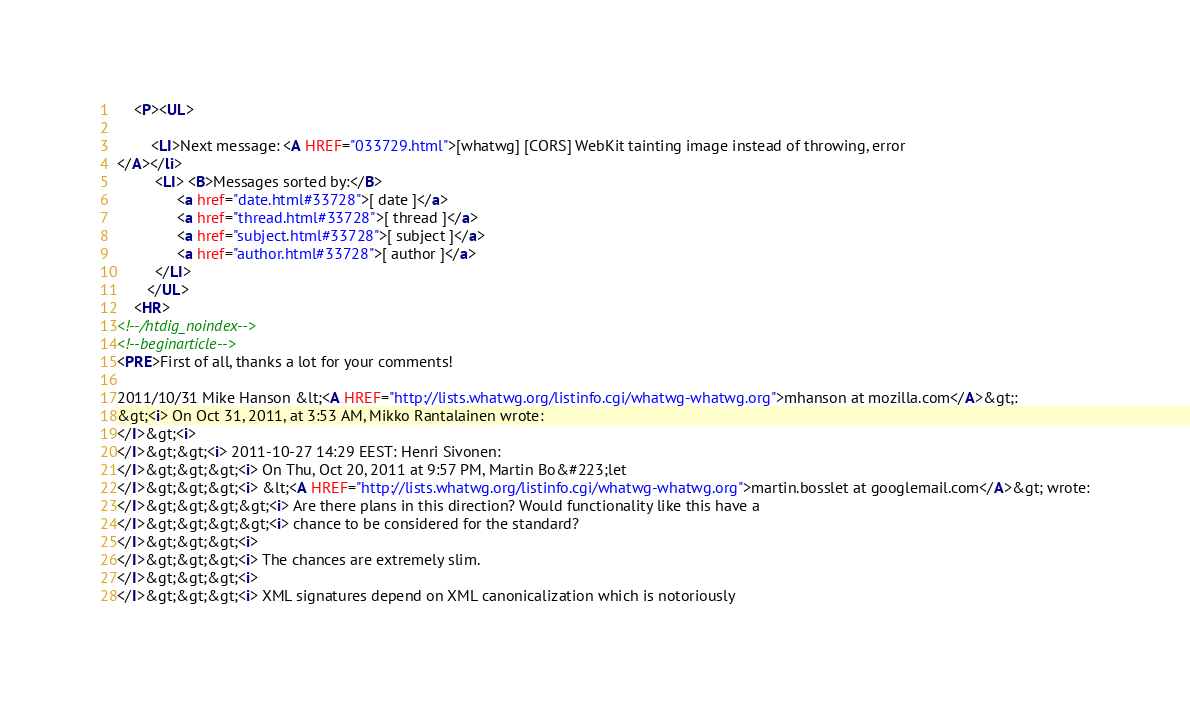<code> <loc_0><loc_0><loc_500><loc_500><_HTML_>    <P><UL>
        
        <LI>Next message: <A HREF="033729.html">[whatwg] [CORS] WebKit tainting image instead of throwing, error
</A></li>
         <LI> <B>Messages sorted by:</B> 
              <a href="date.html#33728">[ date ]</a>
              <a href="thread.html#33728">[ thread ]</a>
              <a href="subject.html#33728">[ subject ]</a>
              <a href="author.html#33728">[ author ]</a>
         </LI>
       </UL>
    <HR>  
<!--/htdig_noindex-->
<!--beginarticle-->
<PRE>First of all, thanks a lot for your comments!

2011/10/31 Mike Hanson &lt;<A HREF="http://lists.whatwg.org/listinfo.cgi/whatwg-whatwg.org">mhanson at mozilla.com</A>&gt;:
&gt;<i> On Oct 31, 2011, at 3:53 AM, Mikko Rantalainen wrote:
</I>&gt;<i>
</I>&gt;&gt;<i> 2011-10-27 14:29 EEST: Henri Sivonen:
</I>&gt;&gt;&gt;<i> On Thu, Oct 20, 2011 at 9:57 PM, Martin Bo&#223;let
</I>&gt;&gt;&gt;<i> &lt;<A HREF="http://lists.whatwg.org/listinfo.cgi/whatwg-whatwg.org">martin.bosslet at googlemail.com</A>&gt; wrote:
</I>&gt;&gt;&gt;&gt;<i> Are there plans in this direction? Would functionality like this have a
</I>&gt;&gt;&gt;&gt;<i> chance to be considered for the standard?
</I>&gt;&gt;&gt;<i>
</I>&gt;&gt;&gt;<i> The chances are extremely slim.
</I>&gt;&gt;&gt;<i>
</I>&gt;&gt;&gt;<i> XML signatures depend on XML canonicalization which is notoriously</code> 